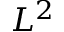Convert formula to latex. <formula><loc_0><loc_0><loc_500><loc_500>L ^ { 2 }</formula> 